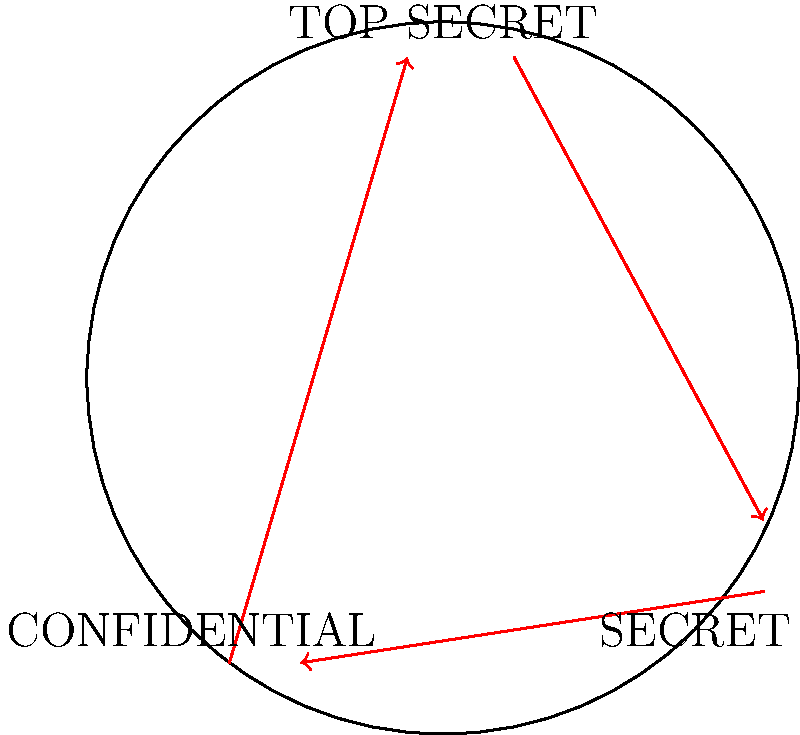In a security clearance system, there are three levels of access: TOP SECRET, SECRET, and CONFIDENTIAL. The system is designed to rotate access levels periodically for enhanced security. If an official's clearance is downgraded by one level every 4 months, how many months will it take for their clearance to return to its original level, assuming continuous rotation? To solve this problem, we need to analyze the cyclic group structure of the rotating access levels:

1. Identify the elements of the group:
   - TOP SECRET
   - SECRET
   - CONFIDENTIAL

2. Understand the rotation pattern:
   TOP SECRET → SECRET → CONFIDENTIAL → TOP SECRET

3. Count the number of elements in the group:
   There are 3 distinct access levels.

4. Calculate the time for one complete rotation:
   - Each downgrade takes 4 months
   - There are 3 downgrades to complete one full cycle
   - Total time = 3 × 4 months = 12 months

5. Verify the cyclic group property:
   After 12 months (3 rotations), the clearance level returns to its original state, satisfying the definition of a cyclic group of order 3.

The system forms a cyclic group of order 3, with each rotation taking 4 months. Therefore, it takes 12 months for an official's clearance to return to its original level.
Answer: 12 months 